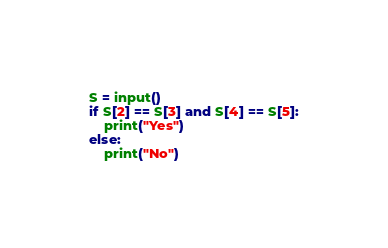Convert code to text. <code><loc_0><loc_0><loc_500><loc_500><_Python_>S = input()
if S[2] == S[3] and S[4] == S[5]:
    print("Yes")
else:
    print("No")</code> 